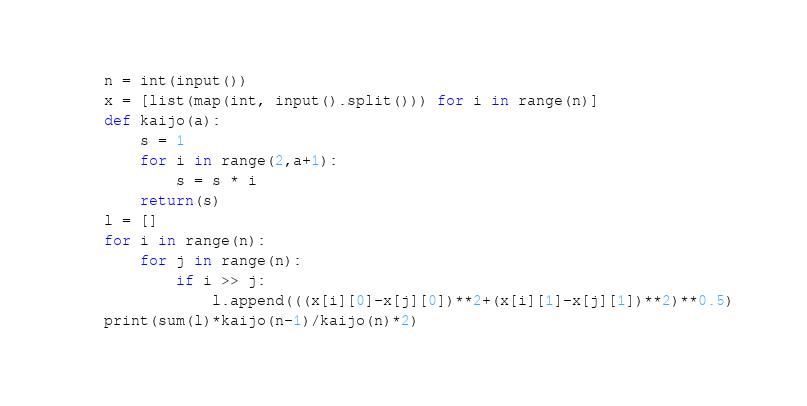Convert code to text. <code><loc_0><loc_0><loc_500><loc_500><_Python_>n = int(input())
x = [list(map(int, input().split())) for i in range(n)]
def kaijo(a):
    s = 1
    for i in range(2,a+1):
        s = s * i
    return(s)
l = []
for i in range(n):
    for j in range(n):
        if i >> j:
            l.append(((x[i][0]-x[j][0])**2+(x[i][1]-x[j][1])**2)**0.5)
print(sum(l)*kaijo(n-1)/kaijo(n)*2)</code> 